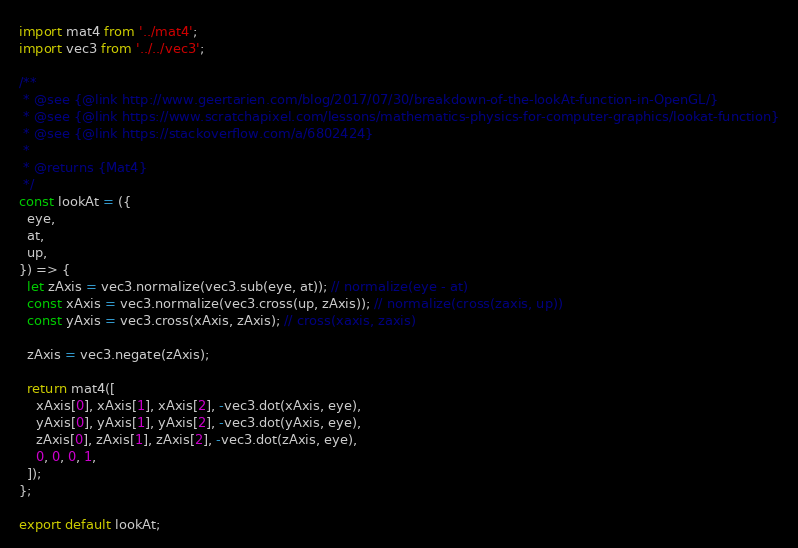<code> <loc_0><loc_0><loc_500><loc_500><_JavaScript_>import mat4 from '../mat4';
import vec3 from '../../vec3';

/**
 * @see {@link http://www.geertarien.com/blog/2017/07/30/breakdown-of-the-lookAt-function-in-OpenGL/}
 * @see {@link https://www.scratchapixel.com/lessons/mathematics-physics-for-computer-graphics/lookat-function}
 * @see {@link https://stackoverflow.com/a/6802424}
 *
 * @returns {Mat4}
 */
const lookAt = ({
  eye,
  at,
  up,
}) => {
  let zAxis = vec3.normalize(vec3.sub(eye, at)); // normalize(eye - at)
  const xAxis = vec3.normalize(vec3.cross(up, zAxis)); // normalize(cross(zaxis, up))
  const yAxis = vec3.cross(xAxis, zAxis); // cross(xaxis, zaxis)

  zAxis = vec3.negate(zAxis);

  return mat4([
    xAxis[0], xAxis[1], xAxis[2], -vec3.dot(xAxis, eye),
    yAxis[0], yAxis[1], yAxis[2], -vec3.dot(yAxis, eye),
    zAxis[0], zAxis[1], zAxis[2], -vec3.dot(zAxis, eye),
    0, 0, 0, 1,
  ]);
};

export default lookAt;
</code> 